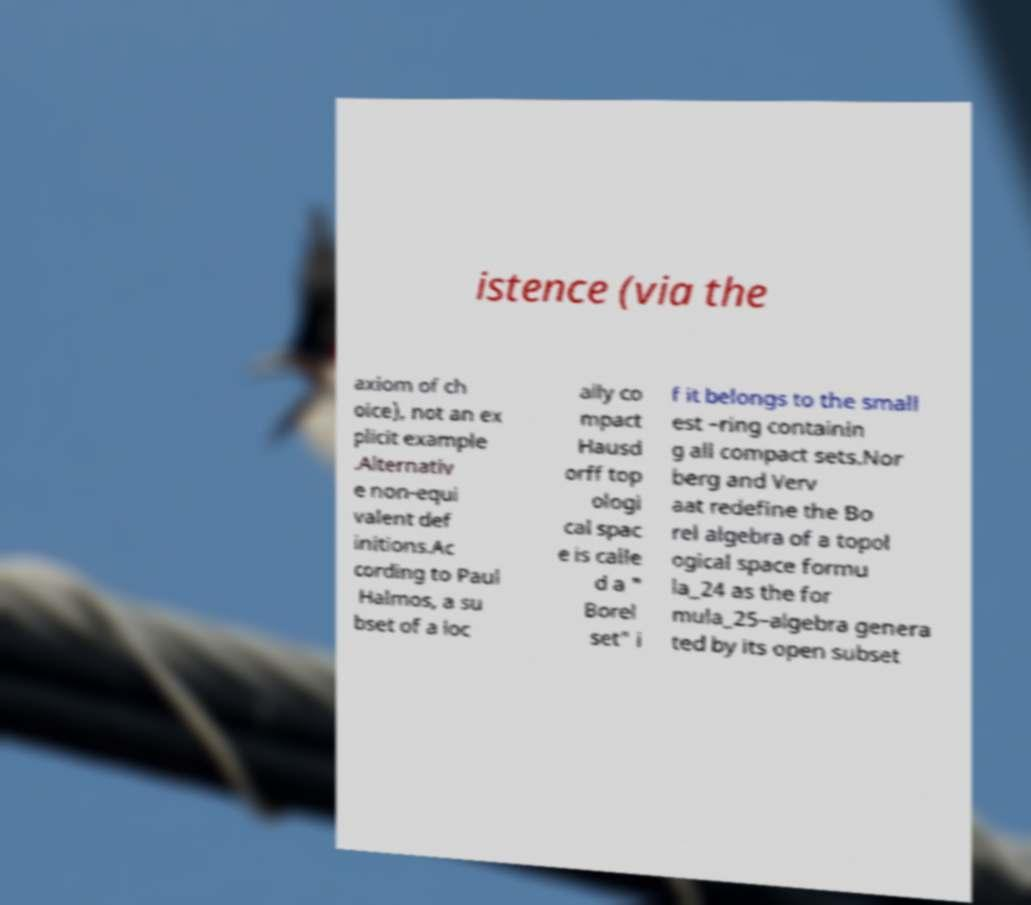Please read and relay the text visible in this image. What does it say? istence (via the axiom of ch oice), not an ex plicit example .Alternativ e non-equi valent def initions.Ac cording to Paul Halmos, a su bset of a loc ally co mpact Hausd orff top ologi cal spac e is calle d a " Borel set" i f it belongs to the small est –ring containin g all compact sets.Nor berg and Verv aat redefine the Bo rel algebra of a topol ogical space formu la_24 as the for mula_25–algebra genera ted by its open subset 